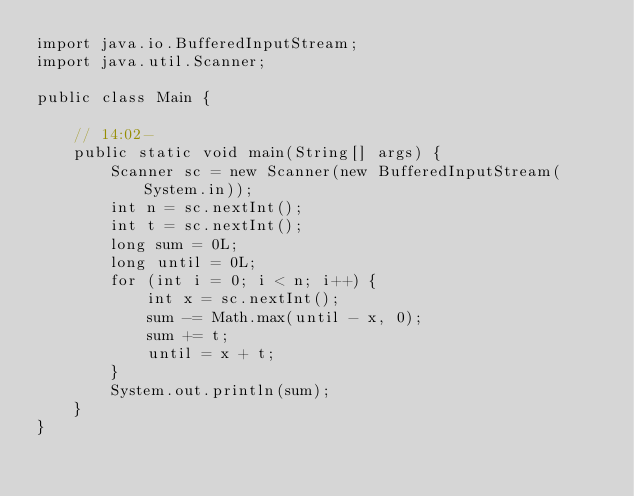<code> <loc_0><loc_0><loc_500><loc_500><_Java_>import java.io.BufferedInputStream;
import java.util.Scanner;

public class Main {

	// 14:02-
	public static void main(String[] args) {
		Scanner sc = new Scanner(new BufferedInputStream(System.in));
		int n = sc.nextInt();
		int t = sc.nextInt();
		long sum = 0L;
		long until = 0L;
		for (int i = 0; i < n; i++) {
			int x = sc.nextInt();
			sum -= Math.max(until - x, 0);
			sum += t;
			until = x + t;
		}
		System.out.println(sum);
	}
}
</code> 